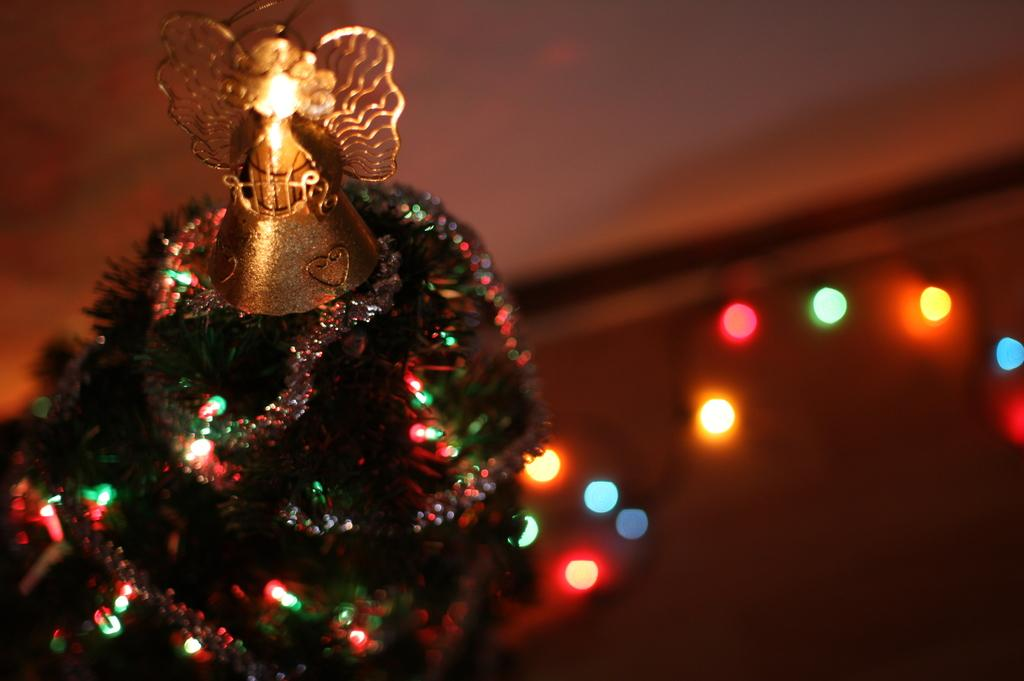What is the main subject of the picture? The main subject of the picture is a Christmas tree. How is the Christmas tree decorated? The Christmas tree is decorated with objects. What can be seen in the background of the image? There are lights in the background of the image. Can you describe the quality of the background in the image? The background of the image is blurred. What type of band is playing in the background of the image? There is no band present in the image; it features a Christmas tree with a blurred background. What type of teeth can be seen in the image? There are no teeth visible in the image, as it features a Christmas tree and a blurred background. 